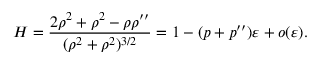<formula> <loc_0><loc_0><loc_500><loc_500>H = \frac { 2 \rho ^ { 2 } + \rho ^ { 2 } - \rho \rho ^ { \prime \prime } } { ( \rho ^ { 2 } + \rho ^ { 2 } ) ^ { 3 / 2 } } = 1 - ( p + p ^ { \prime \prime } ) \varepsilon + o ( \varepsilon ) .</formula> 